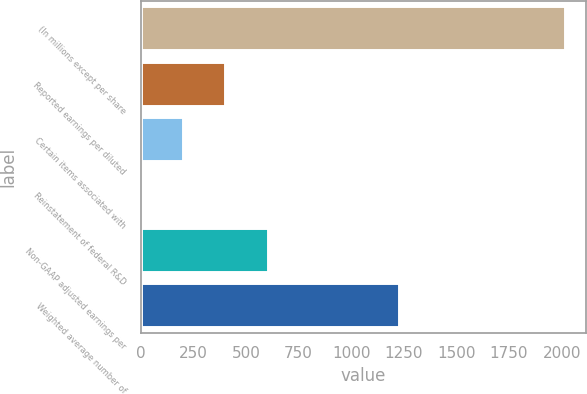Convert chart. <chart><loc_0><loc_0><loc_500><loc_500><bar_chart><fcel>(In millions except per share<fcel>Reported earnings per diluted<fcel>Certain items associated with<fcel>Reinstatement of federal R&D<fcel>Non-GAAP adjusted earnings per<fcel>Weighted average number of<nl><fcel>2015<fcel>403.07<fcel>201.58<fcel>0.09<fcel>604.56<fcel>1226<nl></chart> 